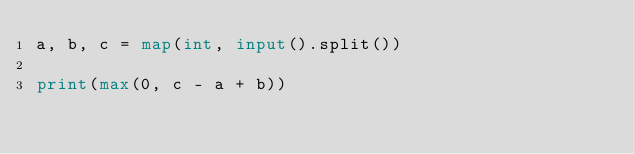<code> <loc_0><loc_0><loc_500><loc_500><_Python_>a, b, c = map(int, input().split())

print(max(0, c - a + b))</code> 